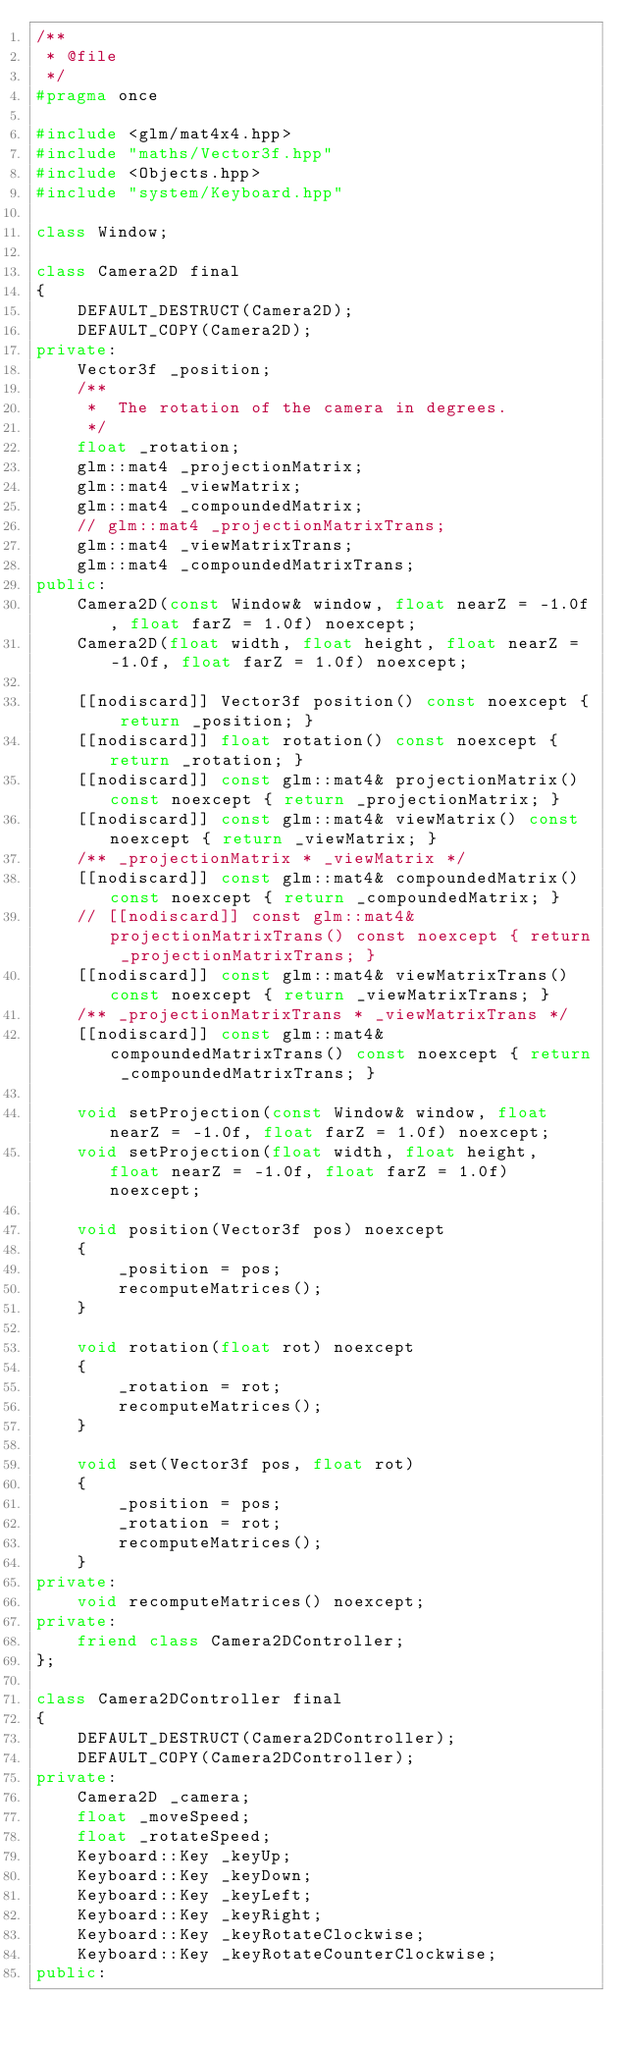Convert code to text. <code><loc_0><loc_0><loc_500><loc_500><_C++_>/**
 * @file
 */
#pragma once

#include <glm/mat4x4.hpp>
#include "maths/Vector3f.hpp"
#include <Objects.hpp>
#include "system/Keyboard.hpp"

class Window;

class Camera2D final
{
    DEFAULT_DESTRUCT(Camera2D);
    DEFAULT_COPY(Camera2D);
private:
    Vector3f _position;
    /**
     *  The rotation of the camera in degrees.
     */
    float _rotation;
    glm::mat4 _projectionMatrix;
    glm::mat4 _viewMatrix;
    glm::mat4 _compoundedMatrix;
    // glm::mat4 _projectionMatrixTrans;
    glm::mat4 _viewMatrixTrans;
    glm::mat4 _compoundedMatrixTrans;
public:
    Camera2D(const Window& window, float nearZ = -1.0f, float farZ = 1.0f) noexcept;
    Camera2D(float width, float height, float nearZ = -1.0f, float farZ = 1.0f) noexcept;

    [[nodiscard]] Vector3f position() const noexcept { return _position; }
    [[nodiscard]] float rotation() const noexcept { return _rotation; }
    [[nodiscard]] const glm::mat4& projectionMatrix() const noexcept { return _projectionMatrix; }
    [[nodiscard]] const glm::mat4& viewMatrix() const noexcept { return _viewMatrix; }
    /** _projectionMatrix * _viewMatrix */
    [[nodiscard]] const glm::mat4& compoundedMatrix() const noexcept { return _compoundedMatrix; }
    // [[nodiscard]] const glm::mat4& projectionMatrixTrans() const noexcept { return _projectionMatrixTrans; }
    [[nodiscard]] const glm::mat4& viewMatrixTrans() const noexcept { return _viewMatrixTrans; }
    /** _projectionMatrixTrans * _viewMatrixTrans */
    [[nodiscard]] const glm::mat4& compoundedMatrixTrans() const noexcept { return _compoundedMatrixTrans; }

    void setProjection(const Window& window, float nearZ = -1.0f, float farZ = 1.0f) noexcept;
    void setProjection(float width, float height, float nearZ = -1.0f, float farZ = 1.0f) noexcept;

    void position(Vector3f pos) noexcept
    {
        _position = pos;
        recomputeMatrices();
    }

    void rotation(float rot) noexcept
    {
        _rotation = rot;
        recomputeMatrices();
    }

    void set(Vector3f pos, float rot)
    {
        _position = pos;
        _rotation = rot;
        recomputeMatrices();
    }
private:
    void recomputeMatrices() noexcept;
private:
    friend class Camera2DController;
};

class Camera2DController final
{
    DEFAULT_DESTRUCT(Camera2DController);
    DEFAULT_COPY(Camera2DController);
private:
    Camera2D _camera;
    float _moveSpeed;
    float _rotateSpeed;
    Keyboard::Key _keyUp;
    Keyboard::Key _keyDown;
    Keyboard::Key _keyLeft;
    Keyboard::Key _keyRight;
    Keyboard::Key _keyRotateClockwise;
    Keyboard::Key _keyRotateCounterClockwise;
public:</code> 